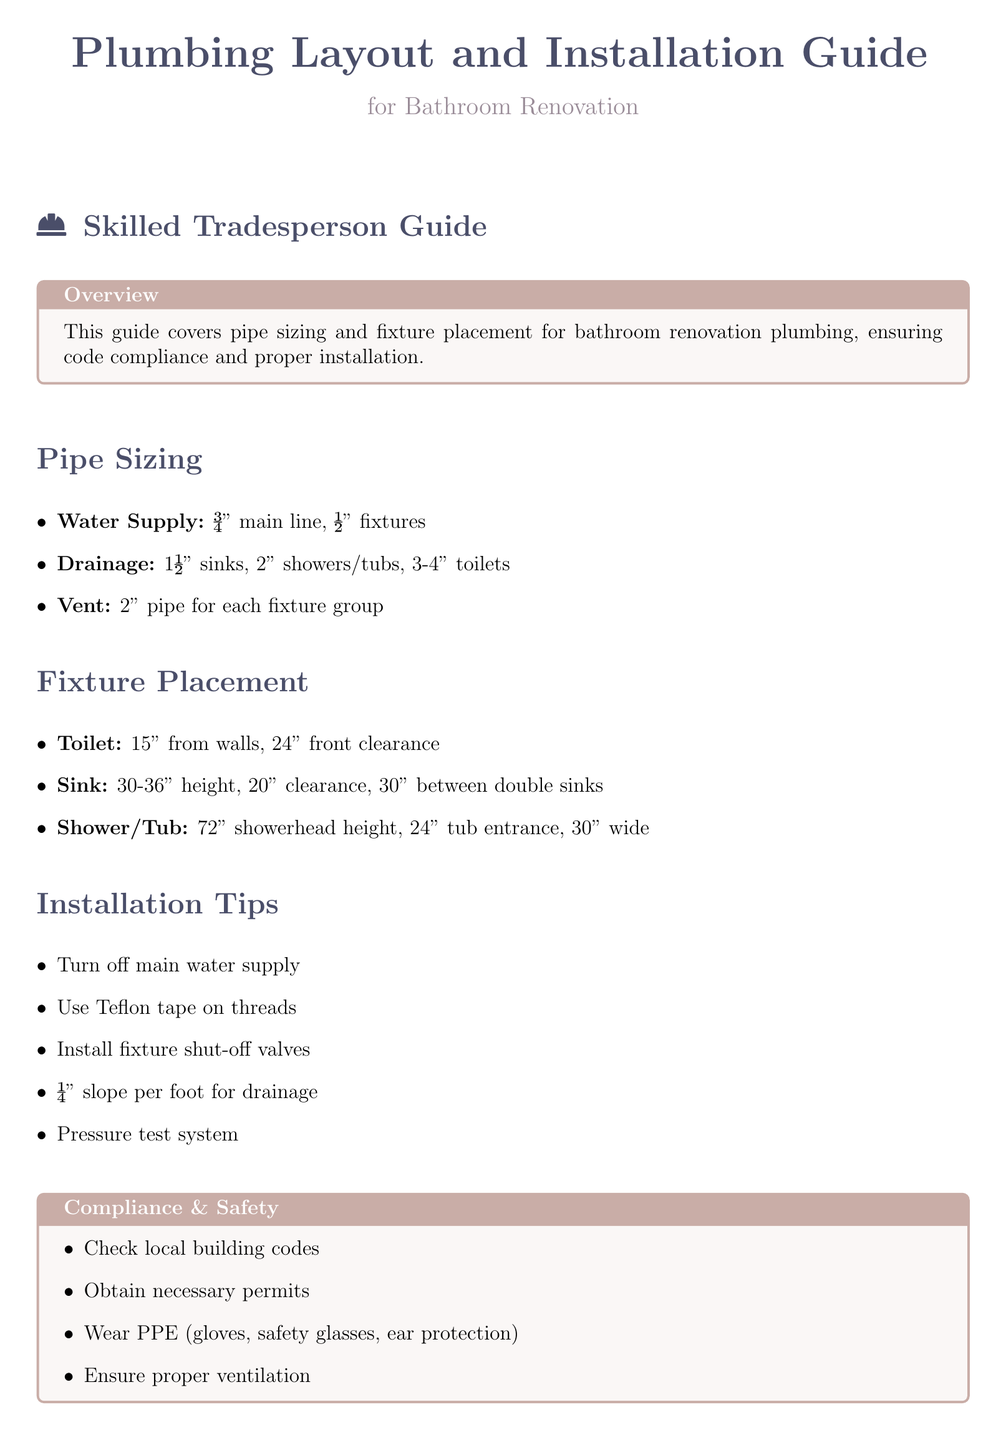What is the main line size for water supply? The main line size for water supply is specified in the Pipe Sizing section of the document.
Answer: ¾" What is the clearance required in front of the toilet? The clearance in front of the toilet is mentioned under Fixture Placement, specifically for the toilet.
Answer: 24" What is the recommended height for sinks? The recommended height for sinks is indicated in the Fixture Placement section.
Answer: 30-36" What slope is recommended for drainage? The recommended slope for drainage is noted in the Installation Tips section of the document.
Answer: ¼" slope per foot What type of pipe is required for venting each fixture group? The type of pipe required for venting is detailed in the Pipe Sizing section.
Answer: 2" pipe What should be turned off before starting the installation? The action to take before installation is highlighted under Installation Tips.
Answer: main water supply What personal protective equipment (PPE) is recommended? The recommended PPE is listed in the Compliance & Safety section.
Answer: gloves, safety glasses, ear protection How far should the showerhead be installed from the floor? The installation height for the showerhead is specified in the Fixture Placement section.
Answer: 72" 